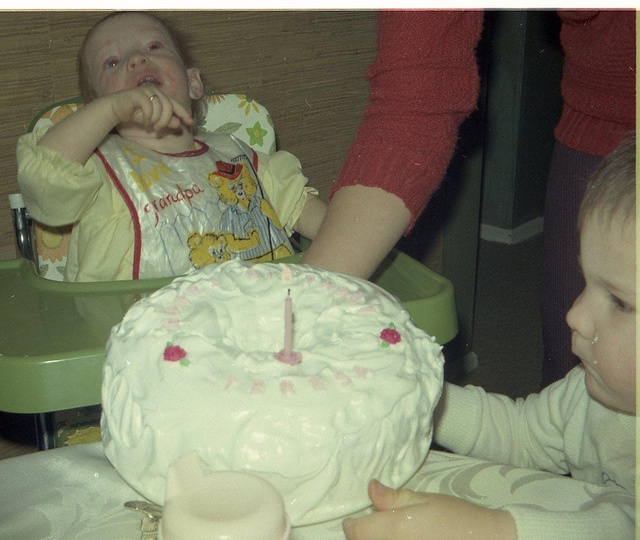Describe the objects in this image and their specific colors. I can see cake in white, beige, and darkgray tones, people in white, olive, gray, and darkgray tones, people in white, gray, and darkgray tones, people in white, maroon, and gray tones, and chair in white, darkgreen, olive, and gray tones in this image. 